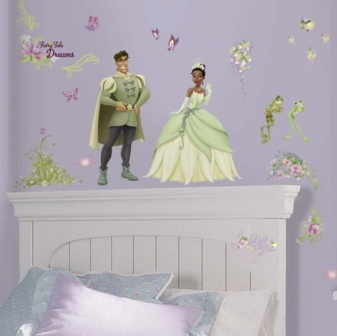Describe a realistic scenario taking place in this bedroom. A realistic scenario might involve a young child preparing for bed, surrounded by their favorite storybooks about princes, princesses, and magical frogs. The child might be tucked in by a parent, who is reading them a bedtime story while the comforting, imaginative decor of the room envelops them with a sense of magic and wonder, ensuring sweet dreams. 